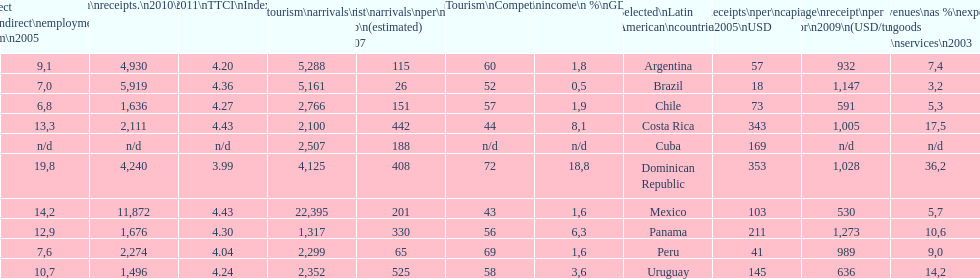How does brazil rank in average receipts per visitor in 2009? 1,147. 